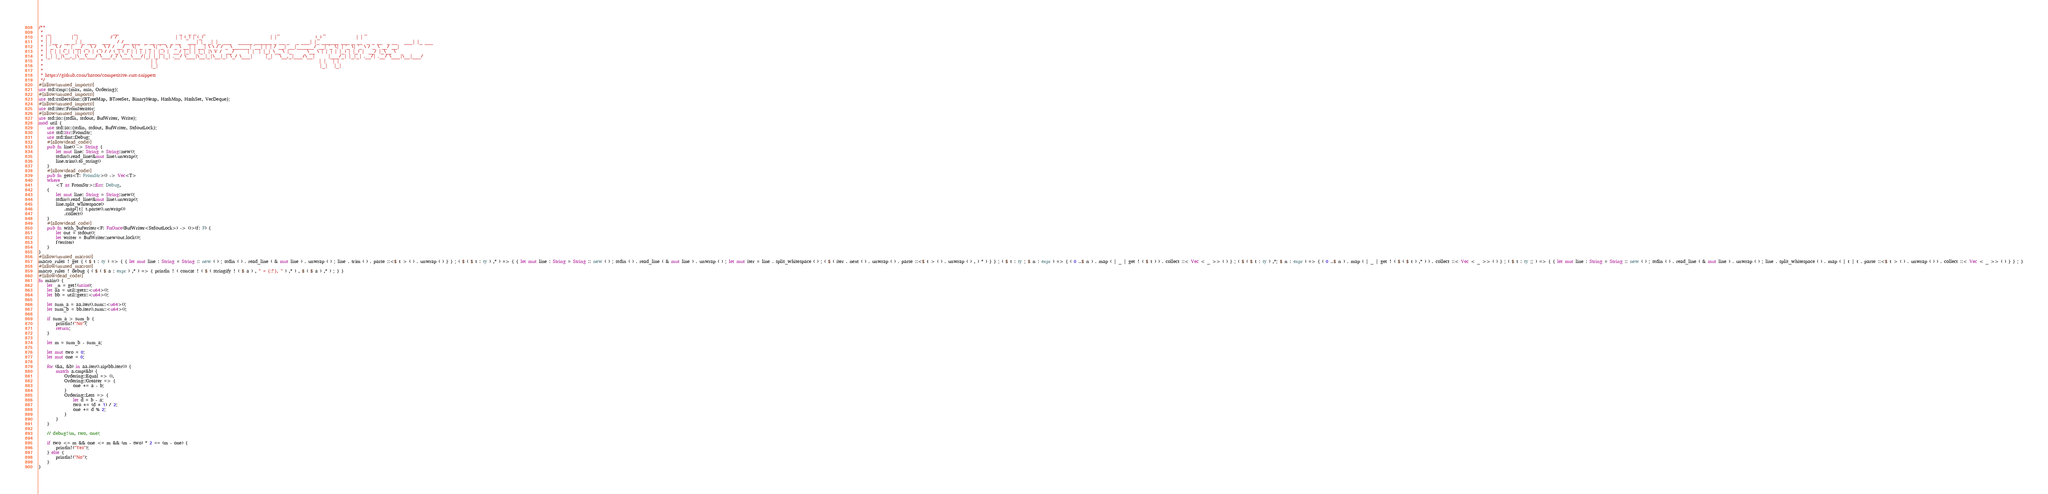<code> <loc_0><loc_0><loc_500><loc_500><_Rust_>/**
 *  _           _                 __                            _   _ _   _                                 _                    _                  _
 * | |         | |               / /                           | | (_) | (_)                               | |                  (_)                | |
 * | |__   __ _| |_ ___   ___   / /__ ___  _ __ ___  _ __   ___| |_ _| |_ ___   _____ ______ _ __ _   _ ___| |_ ______ ___ _ __  _ _ __  _ __   ___| |_ ___
 * | '_ \ / _` | __/ _ \ / _ \ / / __/ _ \| '_ ` _ \| '_ \ / _ \ __| | __| \ \ / / _ \______| '__| | | / __| __|______/ __| '_ \| | '_ \| '_ \ / _ \ __/ __|
 * | | | | (_| | || (_) | (_) / / (_| (_) | | | | | | |_) |  __/ |_| | |_| |\ V /  __/      | |  | |_| \__ \ |_       \__ \ | | | | |_) | |_) |  __/ |_\__ \
 * |_| |_|\__,_|\__\___/ \___/_/ \___\___/|_| |_| |_| .__/ \___|\__|_|\__|_| \_/ \___|      |_|   \__,_|___/\__|      |___/_| |_|_| .__/| .__/ \___|\__|___/
 *                                                  | |                                                                           | |   | |
 *                                                  |_|                                                                           |_|   |_|
 *
 * https://github.com/hatoo/competitive-rust-snippets
 */
#[allow(unused_imports)]
use std::cmp::{max, min, Ordering};
#[allow(unused_imports)]
use std::collections::{BTreeMap, BTreeSet, BinaryHeap, HashMap, HashSet, VecDeque};
#[allow(unused_imports)]
use std::iter::FromIterator;
#[allow(unused_imports)]
use std::io::{stdin, stdout, BufWriter, Write};
mod util {
    use std::io::{stdin, stdout, BufWriter, StdoutLock};
    use std::str::FromStr;
    use std::fmt::Debug;
    #[allow(dead_code)]
    pub fn line() -> String {
        let mut line: String = String::new();
        stdin().read_line(&mut line).unwrap();
        line.trim().to_string()
    }
    #[allow(dead_code)]
    pub fn gets<T: FromStr>() -> Vec<T>
    where
        <T as FromStr>::Err: Debug,
    {
        let mut line: String = String::new();
        stdin().read_line(&mut line).unwrap();
        line.split_whitespace()
            .map(|t| t.parse().unwrap())
            .collect()
    }
    #[allow(dead_code)]
    pub fn with_bufwriter<F: FnOnce(BufWriter<StdoutLock>) -> ()>(f: F) {
        let out = stdout();
        let writer = BufWriter::new(out.lock());
        f(writer)
    }
}
#[allow(unused_macros)]
macro_rules ! get { ( $ t : ty ) => { { let mut line : String = String :: new ( ) ; stdin ( ) . read_line ( & mut line ) . unwrap ( ) ; line . trim ( ) . parse ::<$ t > ( ) . unwrap ( ) } } ; ( $ ( $ t : ty ) ,* ) => { { let mut line : String = String :: new ( ) ; stdin ( ) . read_line ( & mut line ) . unwrap ( ) ; let mut iter = line . split_whitespace ( ) ; ( $ ( iter . next ( ) . unwrap ( ) . parse ::<$ t > ( ) . unwrap ( ) , ) * ) } } ; ( $ t : ty ; $ n : expr ) => { ( 0 ..$ n ) . map ( | _ | get ! ( $ t ) ) . collect ::< Vec < _ >> ( ) } ; ( $ ( $ t : ty ) ,*; $ n : expr ) => { ( 0 ..$ n ) . map ( | _ | get ! ( $ ( $ t ) ,* ) ) . collect ::< Vec < _ >> ( ) } ; ( $ t : ty ;; ) => { { let mut line : String = String :: new ( ) ; stdin ( ) . read_line ( & mut line ) . unwrap ( ) ; line . split_whitespace ( ) . map ( | t | t . parse ::<$ t > ( ) . unwrap ( ) ) . collect ::< Vec < _ >> ( ) } } ; }
#[allow(unused_macros)]
macro_rules ! debug { ( $ ( $ a : expr ) ,* ) => { println ! ( concat ! ( $ ( stringify ! ( $ a ) , " = {:?}, " ) ,* ) , $ ( $ a ) ,* ) ; } }
#[allow(dead_code)]
fn main() {
    let _n = get!(usize);
    let aa = util::gets::<u64>();
    let bb = util::gets::<u64>();

    let sum_a = aa.iter().sum::<u64>();
    let sum_b = bb.iter().sum::<u64>();

    if sum_a > sum_b {
        println!("No");
        return;
    }

    let m = sum_b - sum_a;

    let mut two = 0;
    let mut one = 0;

    for (&a, &b) in aa.iter().zip(bb.iter()) {
        match a.cmp(&b) {
            Ordering::Equal => (),
            Ordering::Greater => {
                one += a - b;
            }
            Ordering::Less => {
                let d = b - a;
                two += (d + 1) / 2;
                one += d % 2;
            }
        }
    }

    // debug!(m, two, one);

    if two <= m && one <= m && (m - two) * 2 == (m - one) {
        println!("Yes");
    } else {
        println!("No");
    }
}
</code> 